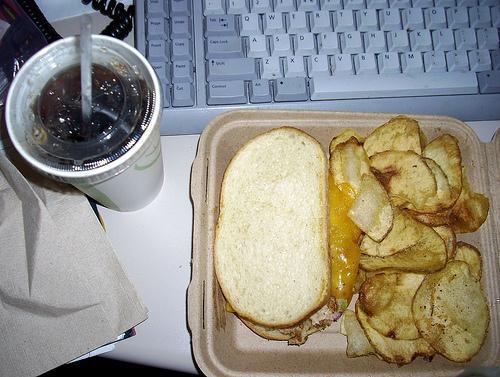How many keyboards are visible?
Give a very brief answer. 1. How many train cars are on the right of the man ?
Give a very brief answer. 0. 